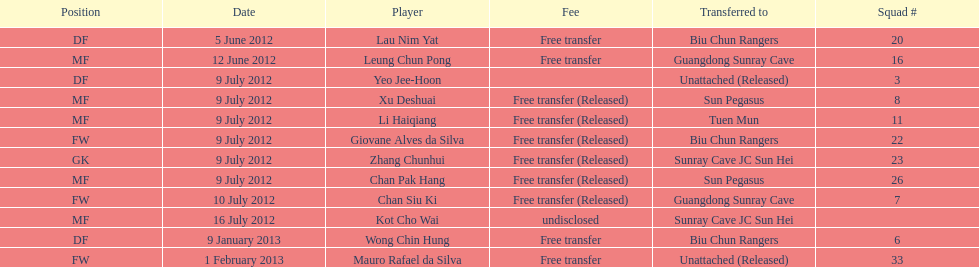What team number is mentioned before team number 7? 26. 